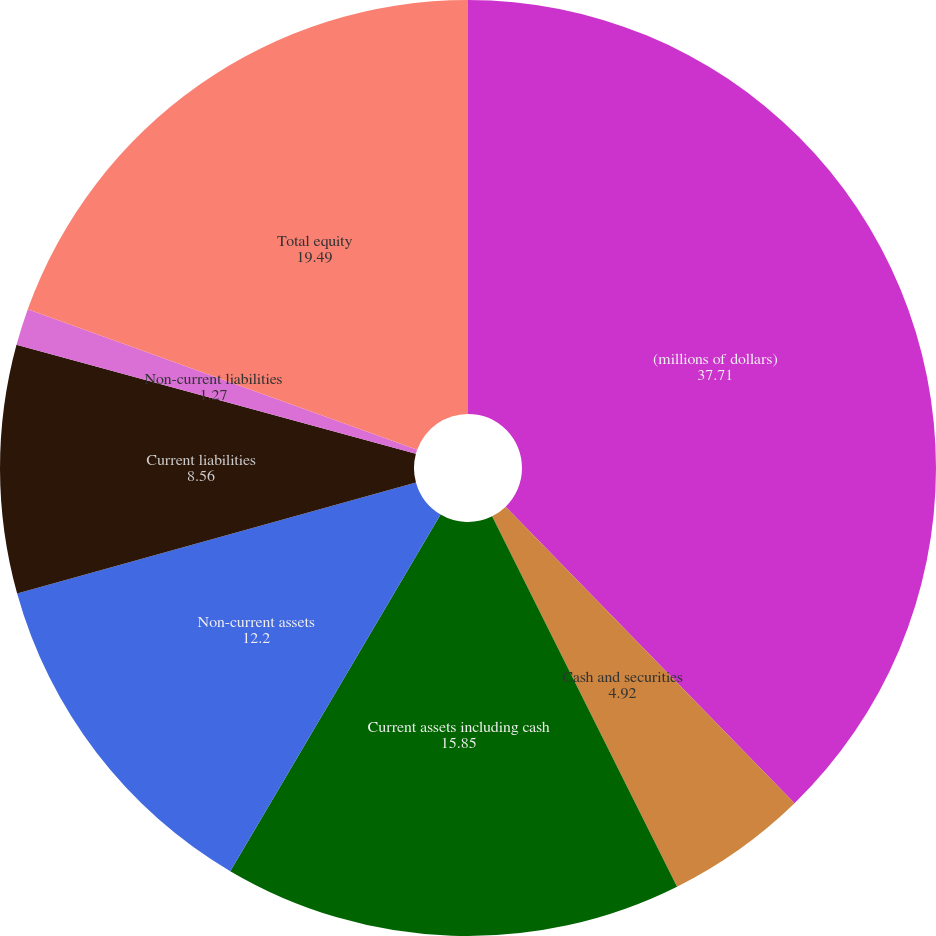Convert chart to OTSL. <chart><loc_0><loc_0><loc_500><loc_500><pie_chart><fcel>(millions of dollars)<fcel>Cash and securities<fcel>Current assets including cash<fcel>Non-current assets<fcel>Current liabilities<fcel>Non-current liabilities<fcel>Total equity<nl><fcel>37.71%<fcel>4.92%<fcel>15.85%<fcel>12.2%<fcel>8.56%<fcel>1.27%<fcel>19.49%<nl></chart> 